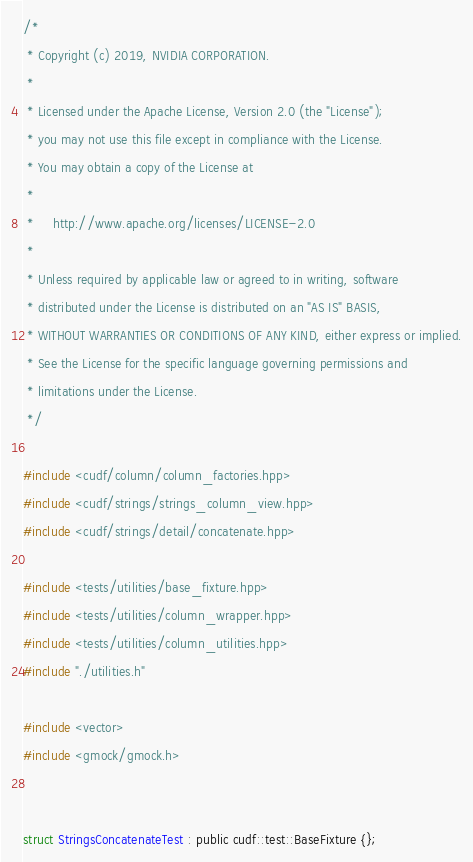<code> <loc_0><loc_0><loc_500><loc_500><_Cuda_>/*
 * Copyright (c) 2019, NVIDIA CORPORATION.
 *
 * Licensed under the Apache License, Version 2.0 (the "License");
 * you may not use this file except in compliance with the License.
 * You may obtain a copy of the License at
 *
 *     http://www.apache.org/licenses/LICENSE-2.0
 *
 * Unless required by applicable law or agreed to in writing, software
 * distributed under the License is distributed on an "AS IS" BASIS,
 * WITHOUT WARRANTIES OR CONDITIONS OF ANY KIND, either express or implied.
 * See the License for the specific language governing permissions and
 * limitations under the License.
 */

#include <cudf/column/column_factories.hpp>
#include <cudf/strings/strings_column_view.hpp>
#include <cudf/strings/detail/concatenate.hpp>

#include <tests/utilities/base_fixture.hpp>
#include <tests/utilities/column_wrapper.hpp>
#include <tests/utilities/column_utilities.hpp>
#include "./utilities.h"

#include <vector>
#include <gmock/gmock.h>


struct StringsConcatenateTest : public cudf::test::BaseFixture {};
</code> 